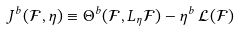<formula> <loc_0><loc_0><loc_500><loc_500>J ^ { b } ( \mathcal { F } , \eta ) \equiv \Theta ^ { b } ( \mathcal { F } , L _ { \eta } \mathcal { F } ) - \eta ^ { b } \, \mathcal { L } ( \mathcal { F } )</formula> 